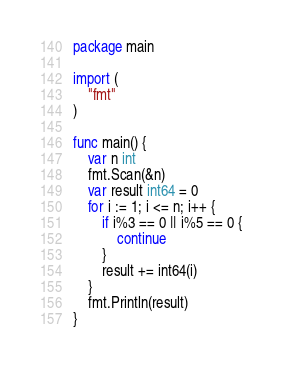Convert code to text. <code><loc_0><loc_0><loc_500><loc_500><_Go_>package main

import (
	"fmt"
)

func main() {
	var n int
	fmt.Scan(&n)
	var result int64 = 0
	for i := 1; i <= n; i++ {
		if i%3 == 0 || i%5 == 0 {
			continue
		}
		result += int64(i)
	}
	fmt.Println(result)
}
</code> 